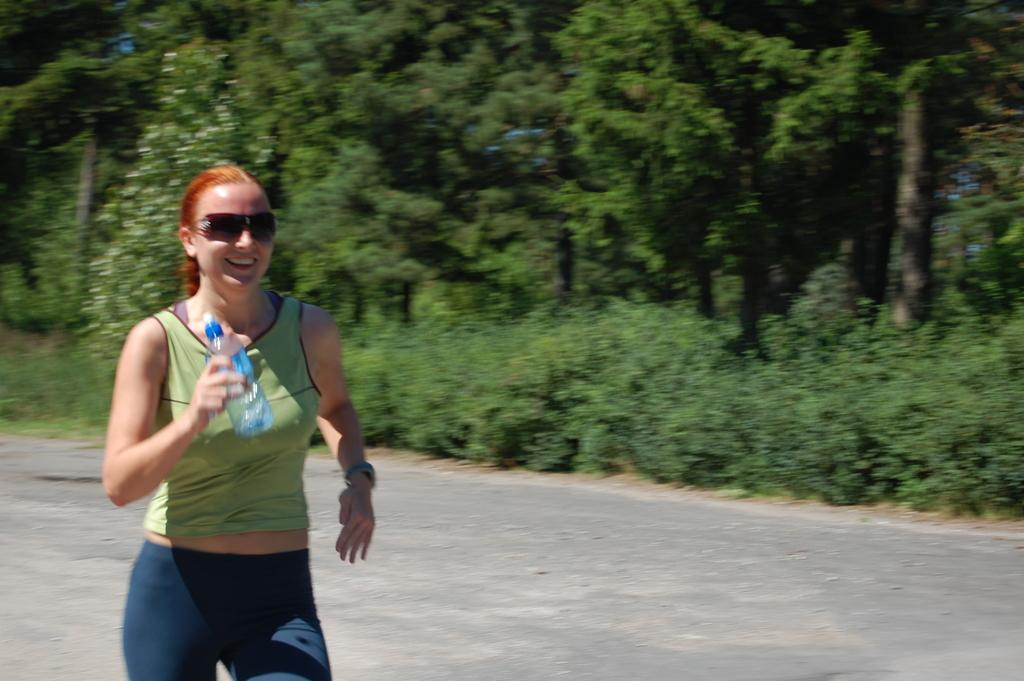Who is the main subject in the image? There is a woman in the image. What is the woman doing in the image? The woman is standing in the image. What object is the woman holding in her hand? The woman is holding a water bottle in her hand. What can be seen in the background of the image? There are trees visible behind the woman. What type of linen is draped over the woman's shoulders in the image? There is no linen draped over the woman's shoulders in the image. 